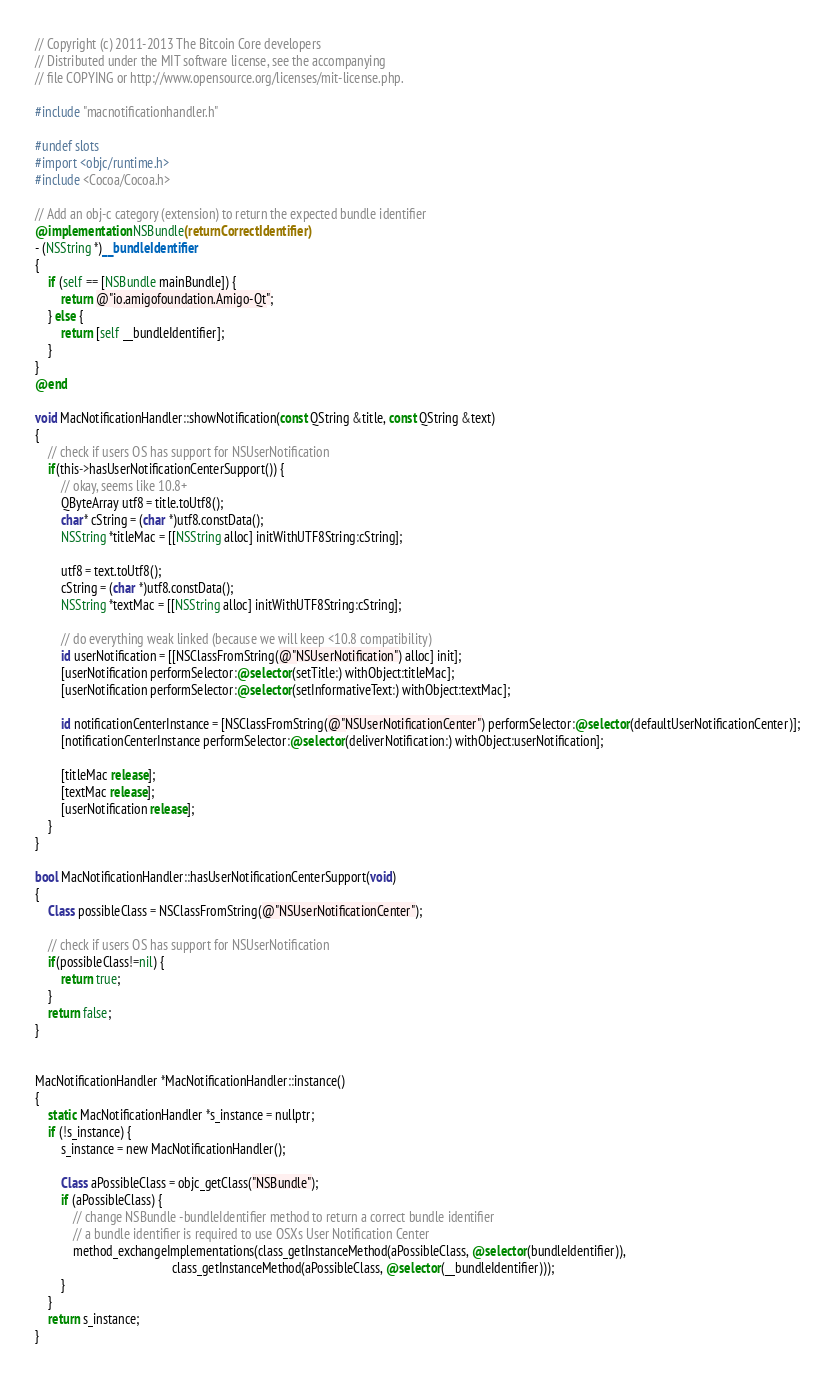Convert code to text. <code><loc_0><loc_0><loc_500><loc_500><_ObjectiveC_>// Copyright (c) 2011-2013 The Bitcoin Core developers
// Distributed under the MIT software license, see the accompanying
// file COPYING or http://www.opensource.org/licenses/mit-license.php.

#include "macnotificationhandler.h"

#undef slots
#import <objc/runtime.h>
#include <Cocoa/Cocoa.h>

// Add an obj-c category (extension) to return the expected bundle identifier
@implementation NSBundle(returnCorrectIdentifier)
- (NSString *)__bundleIdentifier
{
    if (self == [NSBundle mainBundle]) {
        return @"io.amigofoundation.Amigo-Qt";
    } else {
        return [self __bundleIdentifier];
    }
}
@end

void MacNotificationHandler::showNotification(const QString &title, const QString &text)
{
    // check if users OS has support for NSUserNotification
    if(this->hasUserNotificationCenterSupport()) {
        // okay, seems like 10.8+
        QByteArray utf8 = title.toUtf8();
        char* cString = (char *)utf8.constData();
        NSString *titleMac = [[NSString alloc] initWithUTF8String:cString];

        utf8 = text.toUtf8();
        cString = (char *)utf8.constData();
        NSString *textMac = [[NSString alloc] initWithUTF8String:cString];

        // do everything weak linked (because we will keep <10.8 compatibility)
        id userNotification = [[NSClassFromString(@"NSUserNotification") alloc] init];
        [userNotification performSelector:@selector(setTitle:) withObject:titleMac];
        [userNotification performSelector:@selector(setInformativeText:) withObject:textMac];

        id notificationCenterInstance = [NSClassFromString(@"NSUserNotificationCenter") performSelector:@selector(defaultUserNotificationCenter)];
        [notificationCenterInstance performSelector:@selector(deliverNotification:) withObject:userNotification];

        [titleMac release];
        [textMac release];
        [userNotification release];
    }
}

bool MacNotificationHandler::hasUserNotificationCenterSupport(void)
{
    Class possibleClass = NSClassFromString(@"NSUserNotificationCenter");

    // check if users OS has support for NSUserNotification
    if(possibleClass!=nil) {
        return true;
    }
    return false;
}


MacNotificationHandler *MacNotificationHandler::instance()
{
    static MacNotificationHandler *s_instance = nullptr;
    if (!s_instance) {
        s_instance = new MacNotificationHandler();
        
        Class aPossibleClass = objc_getClass("NSBundle");
        if (aPossibleClass) {
            // change NSBundle -bundleIdentifier method to return a correct bundle identifier
            // a bundle identifier is required to use OSXs User Notification Center
            method_exchangeImplementations(class_getInstanceMethod(aPossibleClass, @selector(bundleIdentifier)),
                                           class_getInstanceMethod(aPossibleClass, @selector(__bundleIdentifier)));
        }
    }
    return s_instance;
}
</code> 